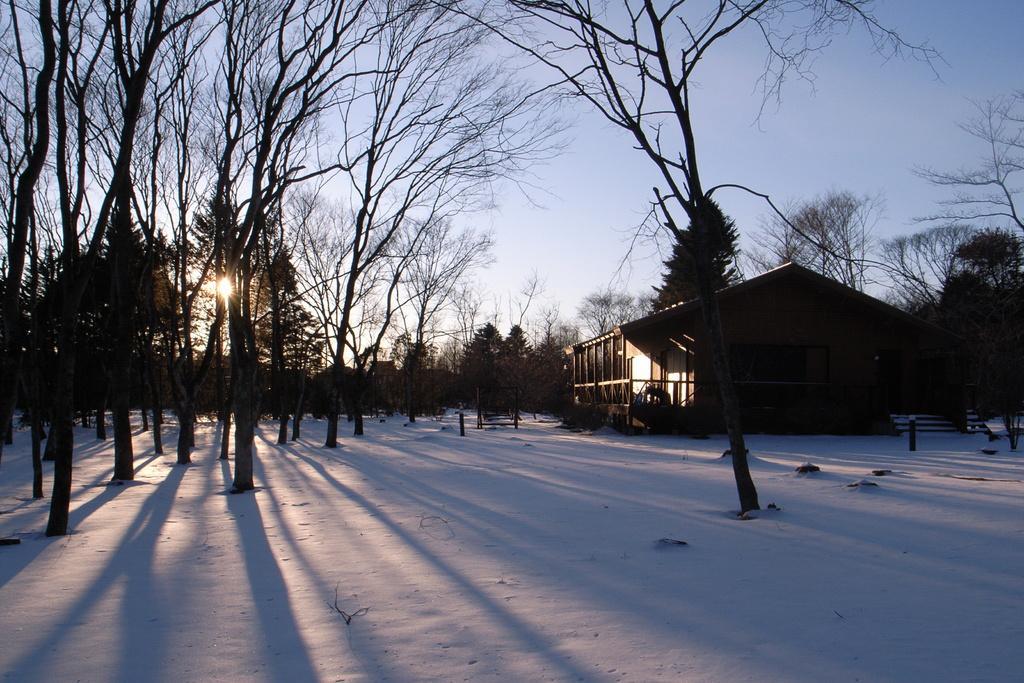Could you give a brief overview of what you see in this image? In this picture we can see a house, snow, trees, poles and in the background we can see the sky. 